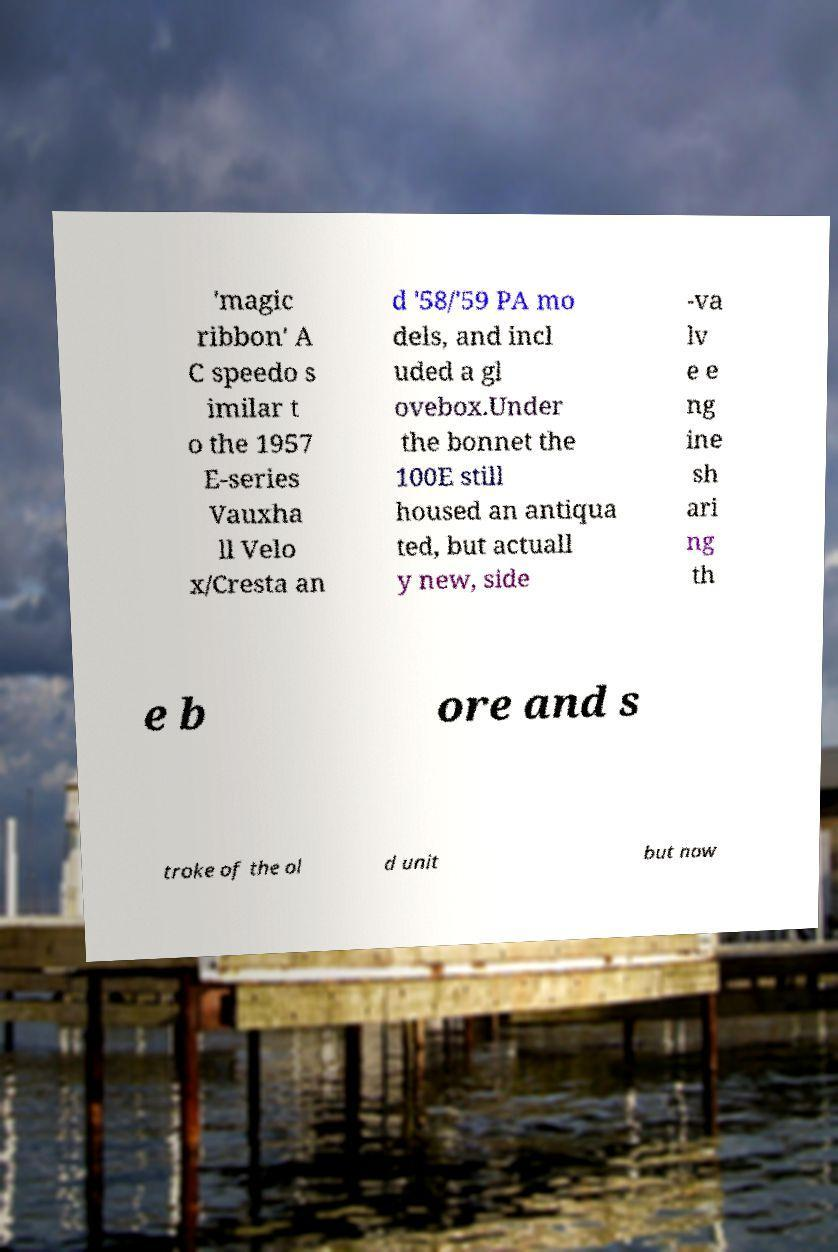I need the written content from this picture converted into text. Can you do that? 'magic ribbon' A C speedo s imilar t o the 1957 E-series Vauxha ll Velo x/Cresta an d '58/'59 PA mo dels, and incl uded a gl ovebox.Under the bonnet the 100E still housed an antiqua ted, but actuall y new, side -va lv e e ng ine sh ari ng th e b ore and s troke of the ol d unit but now 